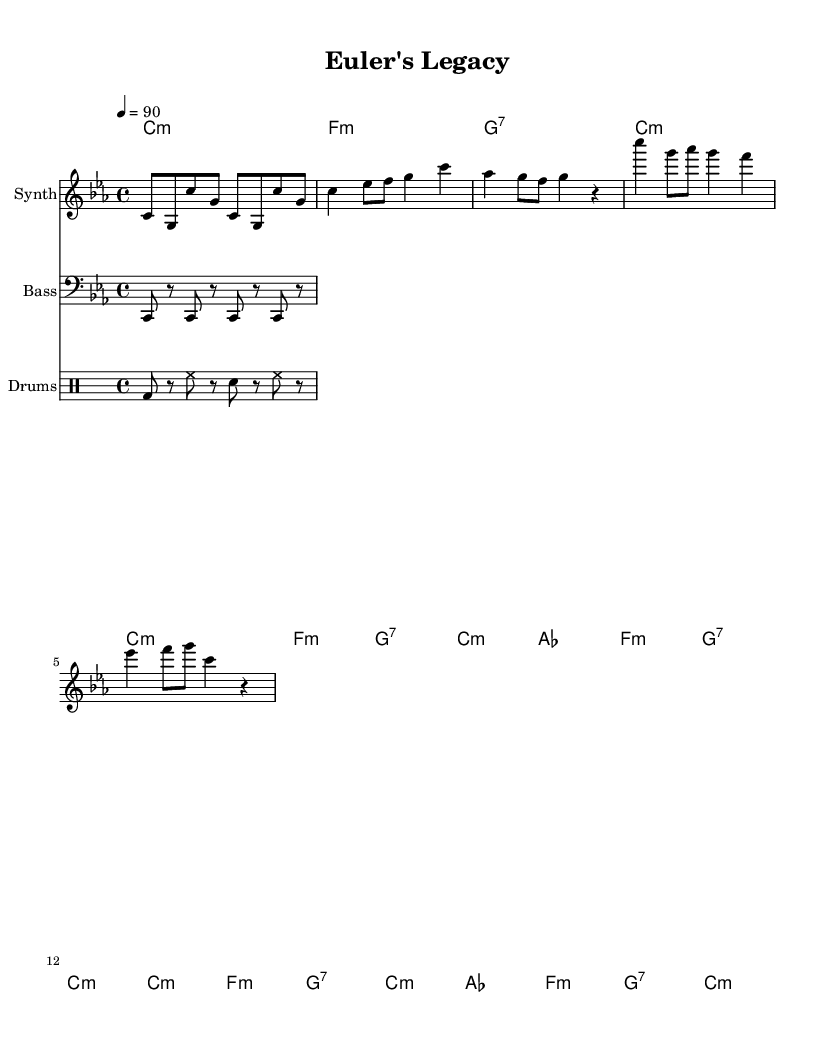What is the key signature of this music? The key signature shown in the music sheet is C minor, which is indicated by three flats.
Answer: C minor What is the time signature of this music? The time signature displayed in the music is 4/4, meaning there are four beats in each measure.
Answer: 4/4 What is the tempo marking for this piece? The tempo marking indicates that the piece should be played at a speed of 90 beats per minute.
Answer: 90 In what style is this music composed? The music is a Hip Hop rap, characterized by its rhythmic vocal delivery and strong beats.
Answer: Hip Hop Which mathematician is the focus of the song? The song centers around the contributions of the mathematician named Euler, a significant figure in mathematics.
Answer: Euler How many measures are there in the verse section? By counting the measures in the verse section, there are a total of four measures present.
Answer: Four What musical elements are primarily used in Hip Hop according to this sheet? The sheet music indicates the use of drums, synthesized melodies, and bass lines, all characteristic of Hip Hop music.
Answer: Drums, synth, bass 